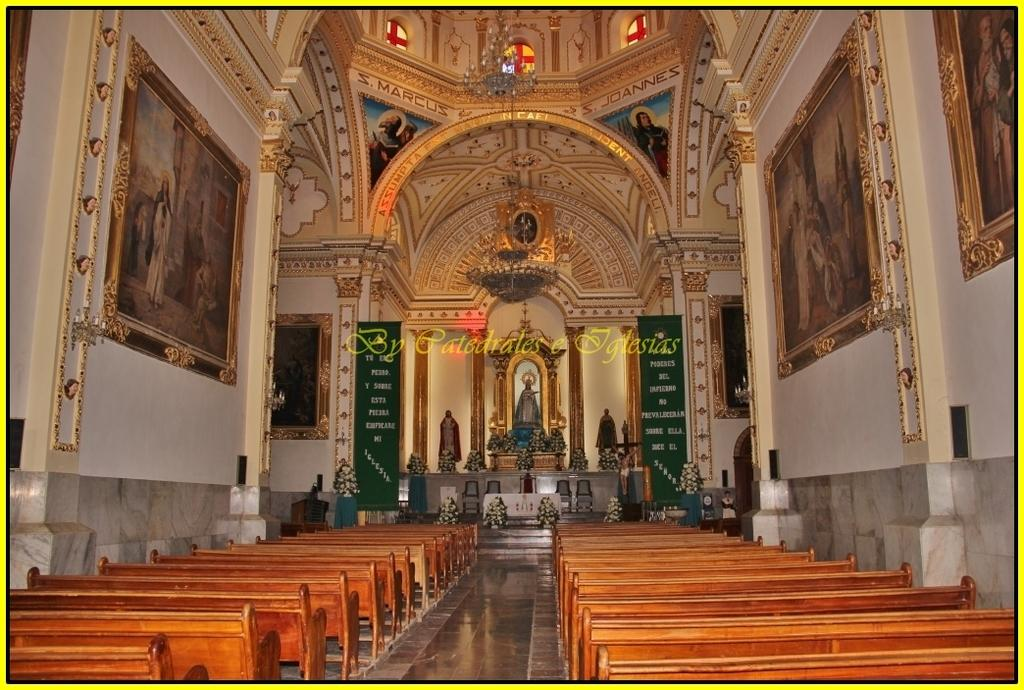What type of seating can be seen in the image? There are benches in the image. What type of artwork is present on a wall in the image? There are wall paintings on a wall in the image. What type of signage or information boards are present in the image? There are boards in the image. What type of greenery is present in the image? There are houseplants in the image. What type of sculptures are present in the image? There are statues in the image. What type of religious figures are present in the image? There are idols in the image. What type of lighting fixture is present in the image? A chandelier is hanged on a rooftop in the image. How many boys are playing with crayons in the image? There are no boys or crayons present in the image. What type of magical creatures can be seen flying around the chandelier in the image? There are no magical creatures present in the image. 